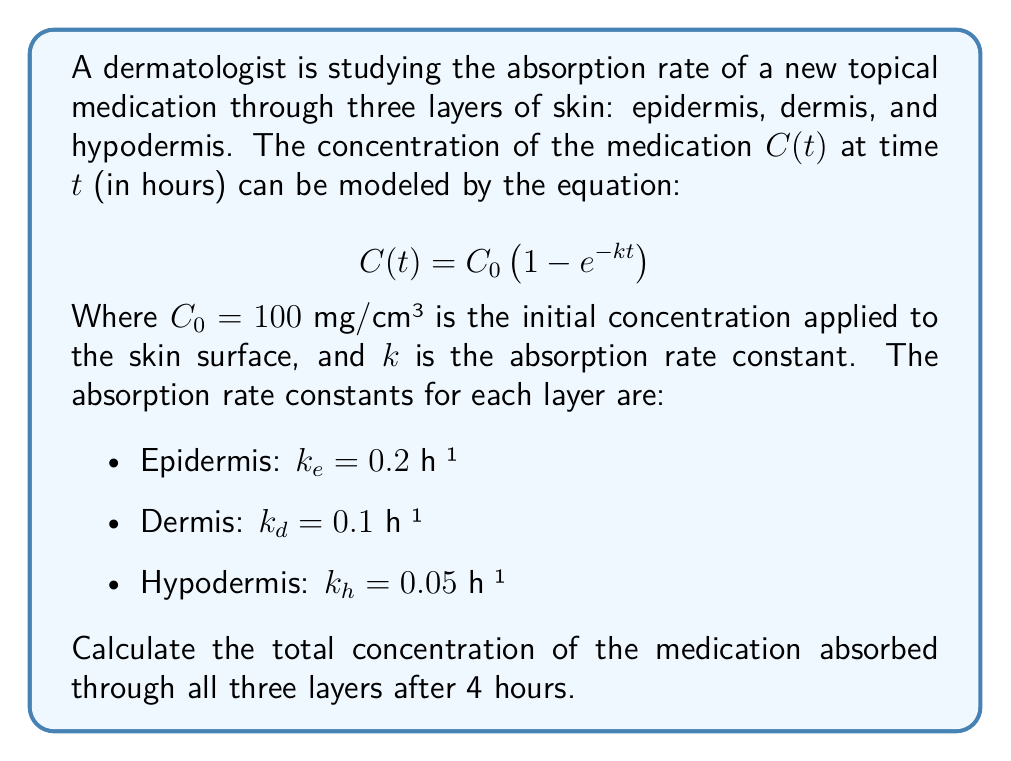Could you help me with this problem? To solve this problem, we need to follow these steps:

1) First, we'll calculate the concentration absorbed by each layer using the given equation:

   $$C(t) = C_0 \left(1 - e^{-kt}\right)$$

2) For the epidermis:
   $$C_e(4) = 100 \left(1 - e^{-0.2 \cdot 4}\right) = 100 \left(1 - e^{-0.8}\right) = 55.07 \text{ mg/cm³}$$

3) For the dermis:
   $$C_d(4) = 100 \left(1 - e^{-0.1 \cdot 4}\right) = 100 \left(1 - e^{-0.4}\right) = 32.97 \text{ mg/cm³}$$

4) For the hypodermis:
   $$C_h(4) = 100 \left(1 - e^{-0.05 \cdot 4}\right) = 100 \left(1 - e^{-0.2}\right) = 18.13 \text{ mg/cm³}$$

5) The total concentration absorbed is the sum of the concentrations absorbed by each layer:

   $$C_{total}(4) = C_e(4) + C_d(4) + C_h(4)$$
   $$C_{total}(4) = 55.07 + 32.97 + 18.13 = 106.17 \text{ mg/cm³}$$

Thus, the total concentration of the medication absorbed through all three layers after 4 hours is approximately 106.17 mg/cm³.
Answer: 106.17 mg/cm³ 